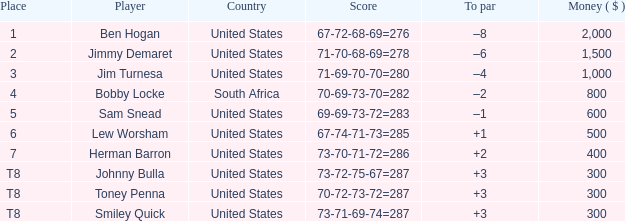Help me parse the entirety of this table. {'header': ['Place', 'Player', 'Country', 'Score', 'To par', 'Money ( $ )'], 'rows': [['1', 'Ben Hogan', 'United States', '67-72-68-69=276', '–8', '2,000'], ['2', 'Jimmy Demaret', 'United States', '71-70-68-69=278', '–6', '1,500'], ['3', 'Jim Turnesa', 'United States', '71-69-70-70=280', '–4', '1,000'], ['4', 'Bobby Locke', 'South Africa', '70-69-73-70=282', '–2', '800'], ['5', 'Sam Snead', 'United States', '69-69-73-72=283', '–1', '600'], ['6', 'Lew Worsham', 'United States', '67-74-71-73=285', '+1', '500'], ['7', 'Herman Barron', 'United States', '73-70-71-72=286', '+2', '400'], ['T8', 'Johnny Bulla', 'United States', '73-72-75-67=287', '+3', '300'], ['T8', 'Toney Penna', 'United States', '70-72-73-72=287', '+3', '300'], ['T8', 'Smiley Quick', 'United States', '73-71-69-74=287', '+3', '300']]} What is the Place of the Player with a To par of –1? 5.0. 